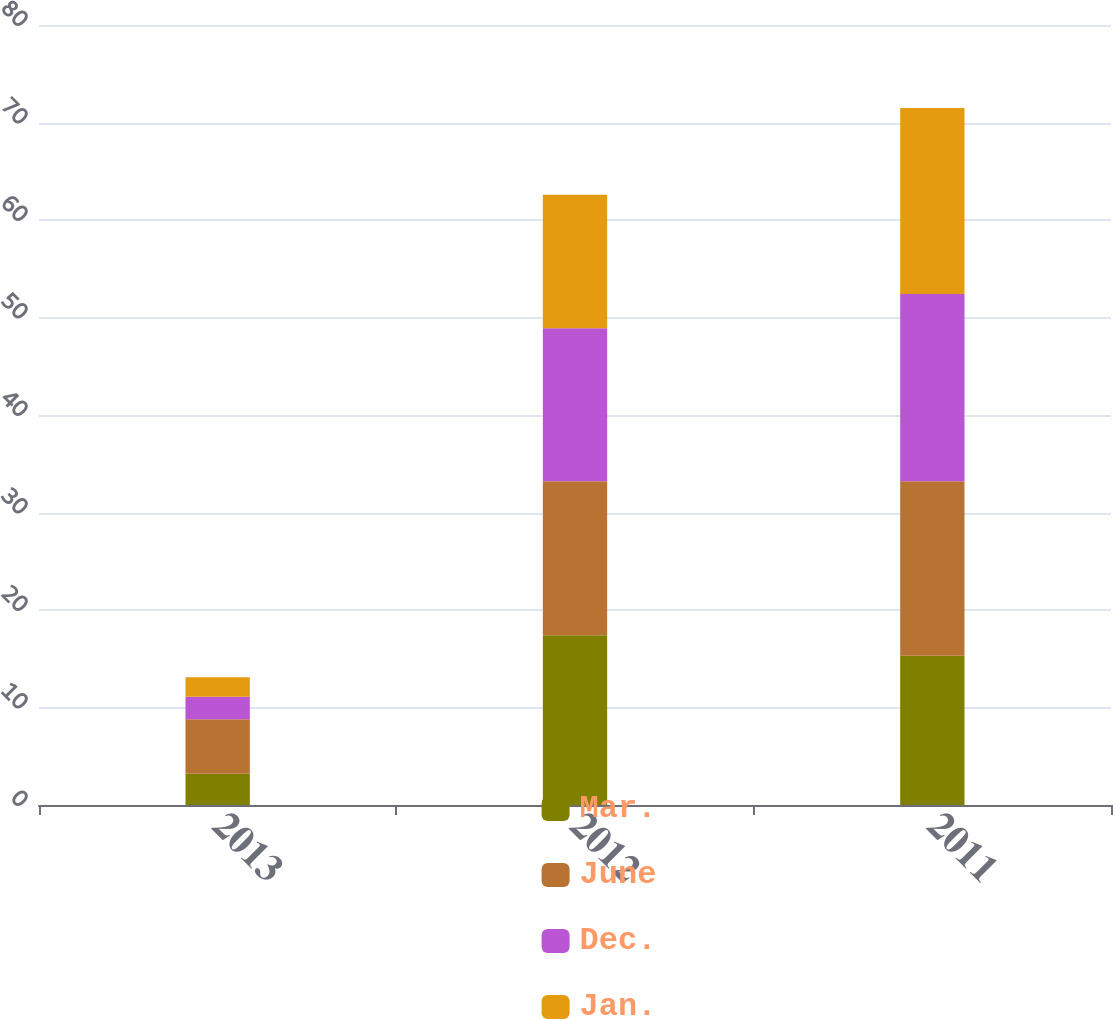Convert chart to OTSL. <chart><loc_0><loc_0><loc_500><loc_500><stacked_bar_chart><ecel><fcel>2013<fcel>2012<fcel>2011<nl><fcel>Mar.<fcel>3.2<fcel>17.4<fcel>15.3<nl><fcel>June<fcel>5.6<fcel>15.8<fcel>17.9<nl><fcel>Dec.<fcel>2.3<fcel>15.7<fcel>19.2<nl><fcel>Jan.<fcel>2<fcel>13.7<fcel>19.1<nl></chart> 